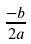<formula> <loc_0><loc_0><loc_500><loc_500>\frac { - b } { 2 a }</formula> 